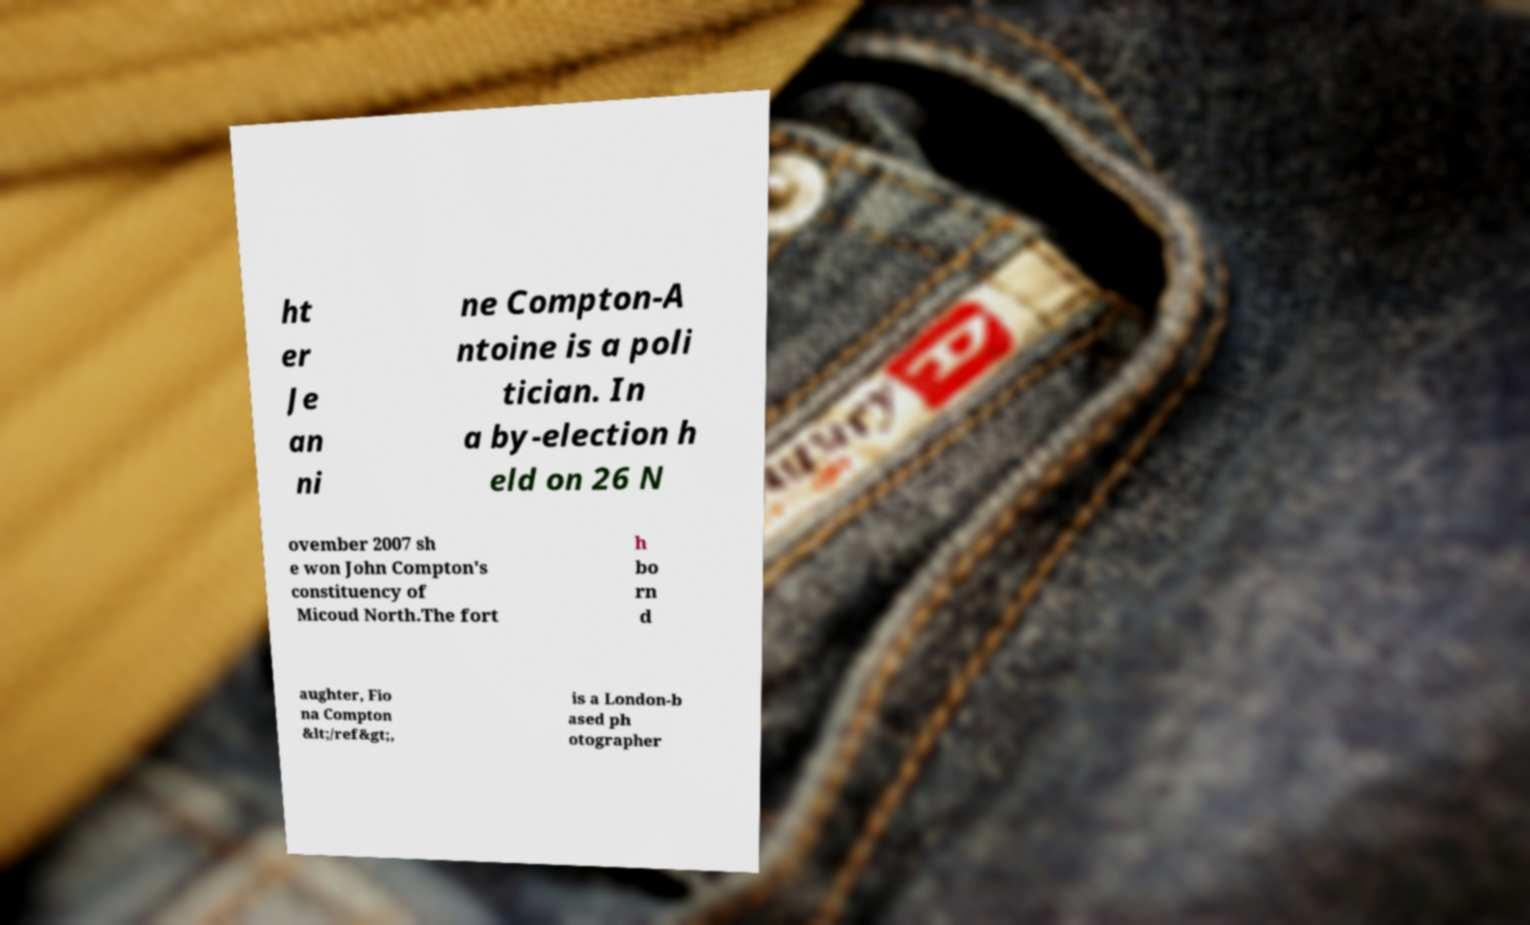What messages or text are displayed in this image? I need them in a readable, typed format. ht er Je an ni ne Compton-A ntoine is a poli tician. In a by-election h eld on 26 N ovember 2007 sh e won John Compton's constituency of Micoud North.The fort h bo rn d aughter, Fio na Compton &lt;/ref&gt;, is a London-b ased ph otographer 